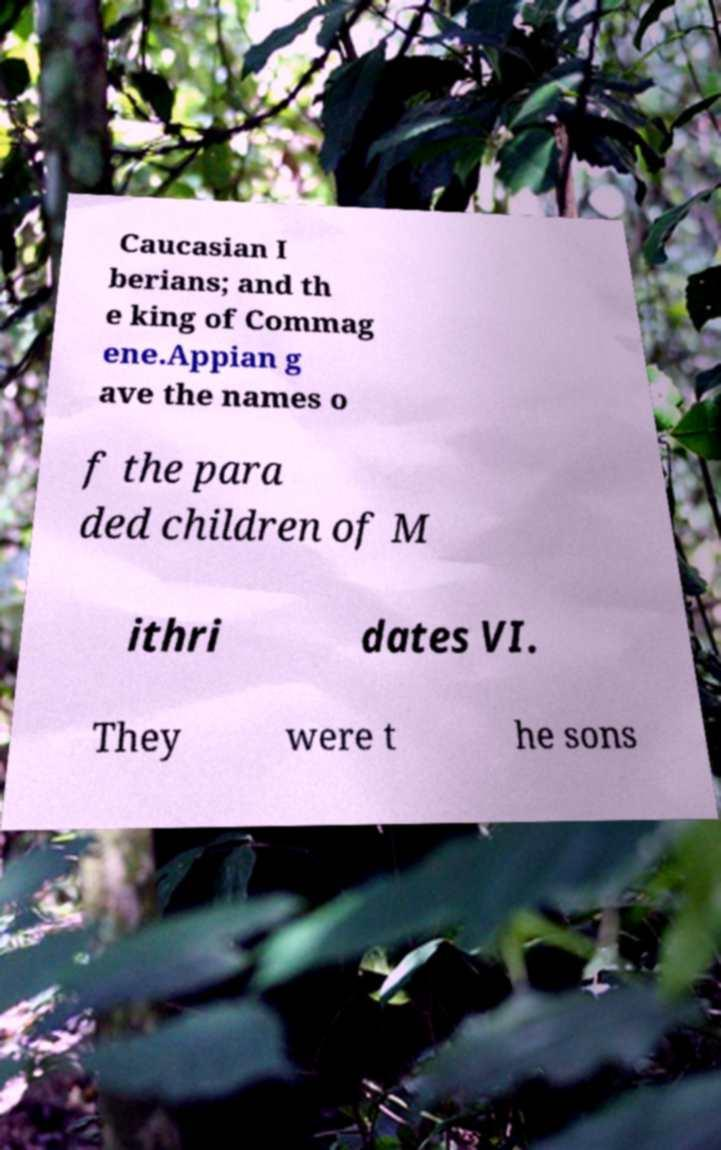Could you assist in decoding the text presented in this image and type it out clearly? Caucasian I berians; and th e king of Commag ene.Appian g ave the names o f the para ded children of M ithri dates VI. They were t he sons 